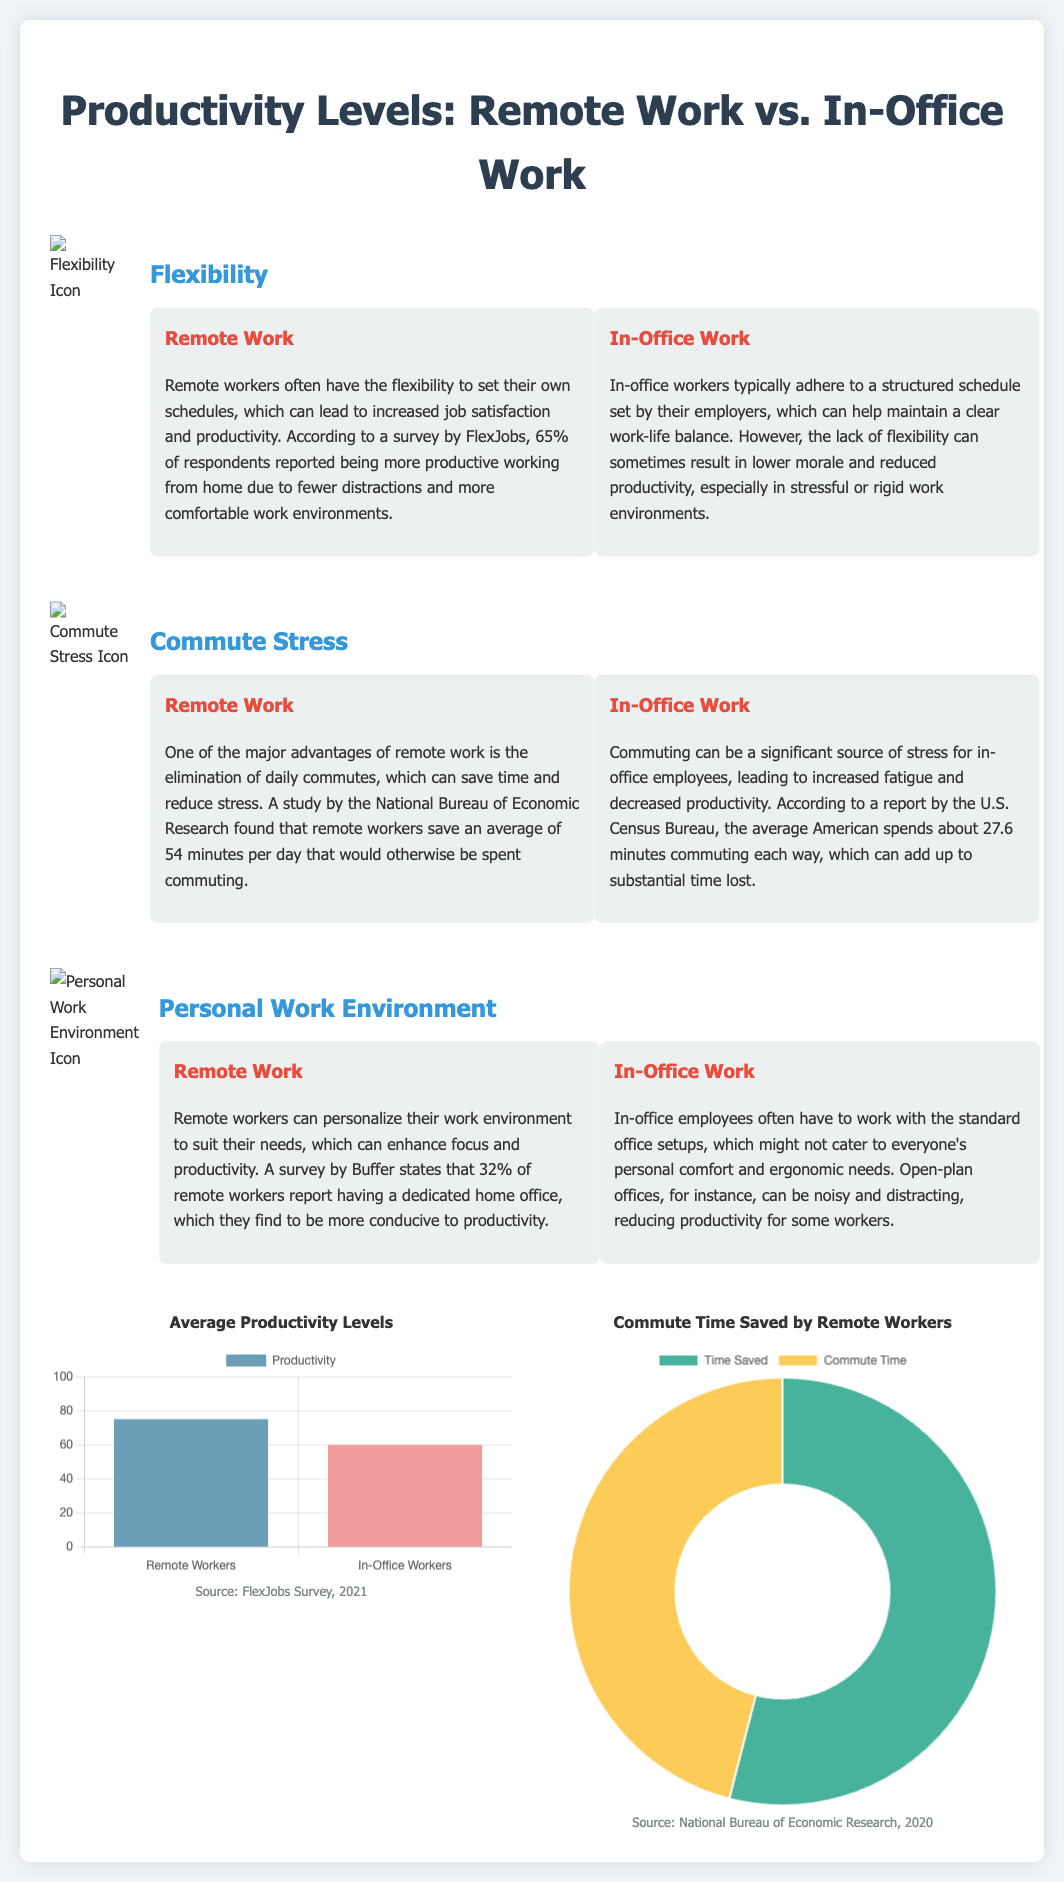What percentage of remote workers reported increased productivity? The document states that 65% of remote workers reported being more productive working from home.
Answer: 65% What is the average time saved by remote workers in their commute? According to the National Bureau of Economic Research, remote workers save an average of 54 minutes per day that would otherwise be spent commuting.
Answer: 54 minutes What is the average productivity level of remote workers? The bar chart indicates that the average productivity level for remote workers is 75.
Answer: 75 What is one of the main stress sources for in-office employees? The document mentions that commuting can be a significant source of stress for in-office employees.
Answer: Commuting What percentage of remote workers have a dedicated home office? A survey by Buffer states that 32% of remote workers report having a dedicated home office.
Answer: 32% What are the two types of charts used in the document? The document utilizes a bar chart for productivity levels and a doughnut chart for commute time saved by remote workers.
Answer: Bar chart and doughnut chart How do in-office work hours typically compare to remote work hours? In-office workers typically adhere to a structured schedule set by their employers, while remote workers have the flexibility to set their own schedules.
Answer: Structured vs. Flexible What is the main subject of the infographic? The infographic primarily compares productivity levels between remote workers and in-office employees.
Answer: Productivity levels comparison 